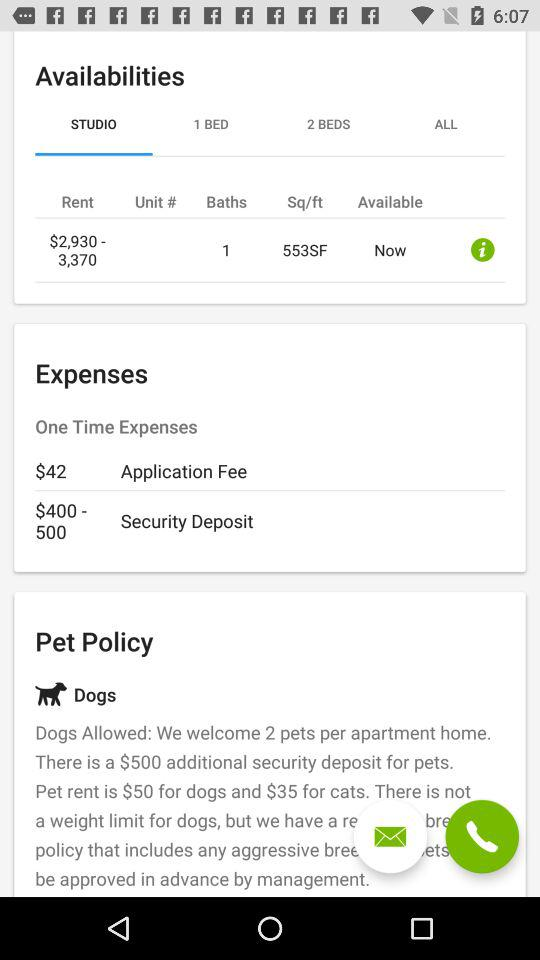How many baths are there? There is 1 bath. 